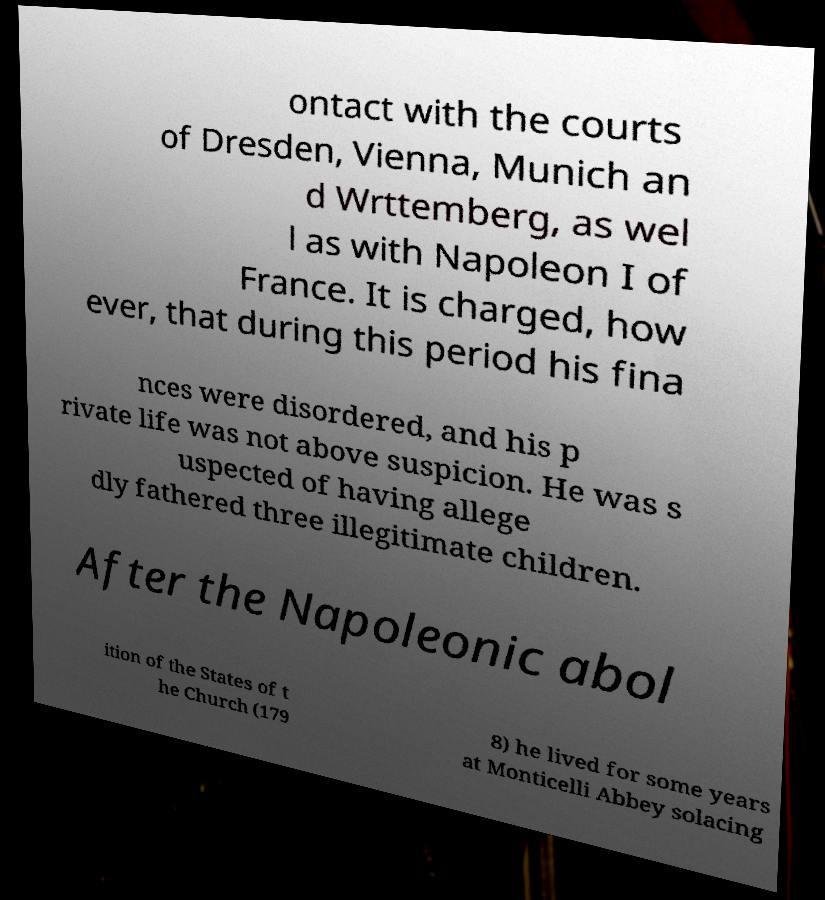Could you assist in decoding the text presented in this image and type it out clearly? ontact with the courts of Dresden, Vienna, Munich an d Wrttemberg, as wel l as with Napoleon I of France. It is charged, how ever, that during this period his fina nces were disordered, and his p rivate life was not above suspicion. He was s uspected of having allege dly fathered three illegitimate children. After the Napoleonic abol ition of the States of t he Church (179 8) he lived for some years at Monticelli Abbey solacing 